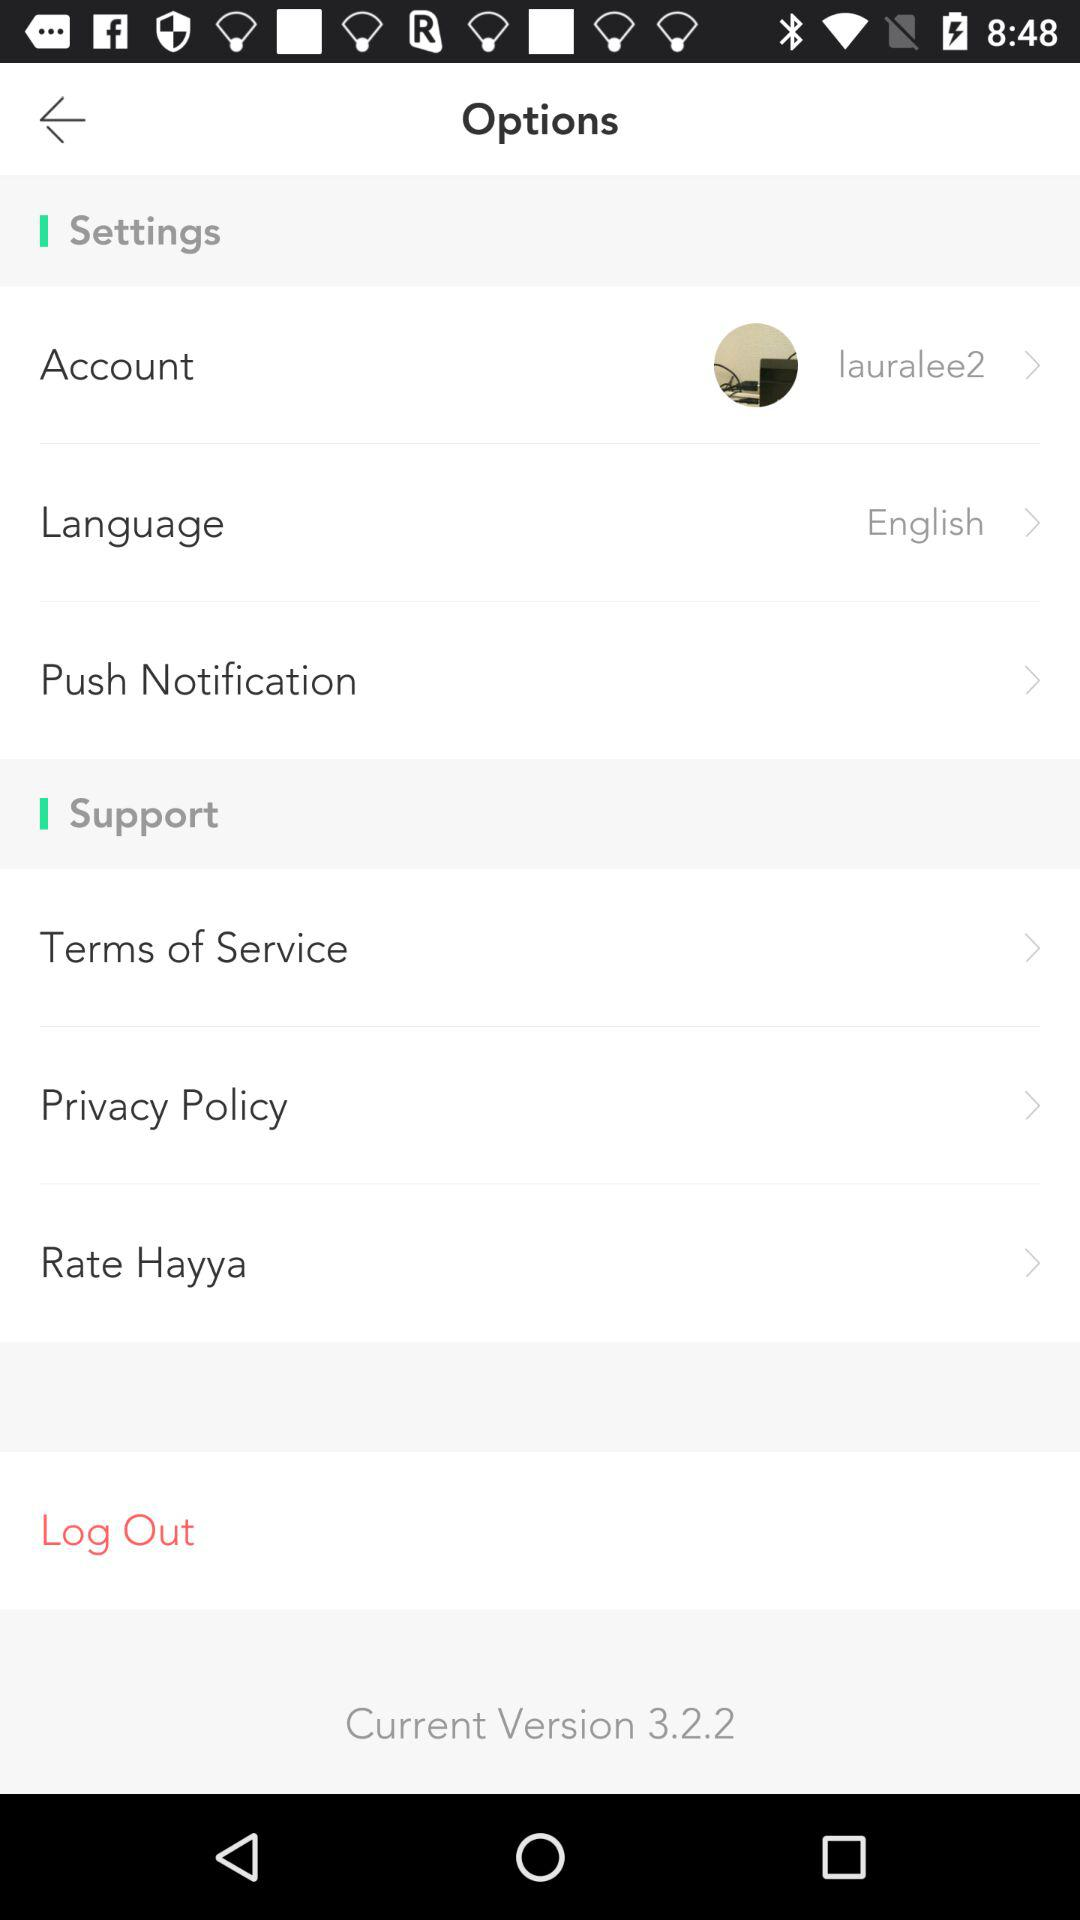What is the current version number? The current version number is 3.2.2. 